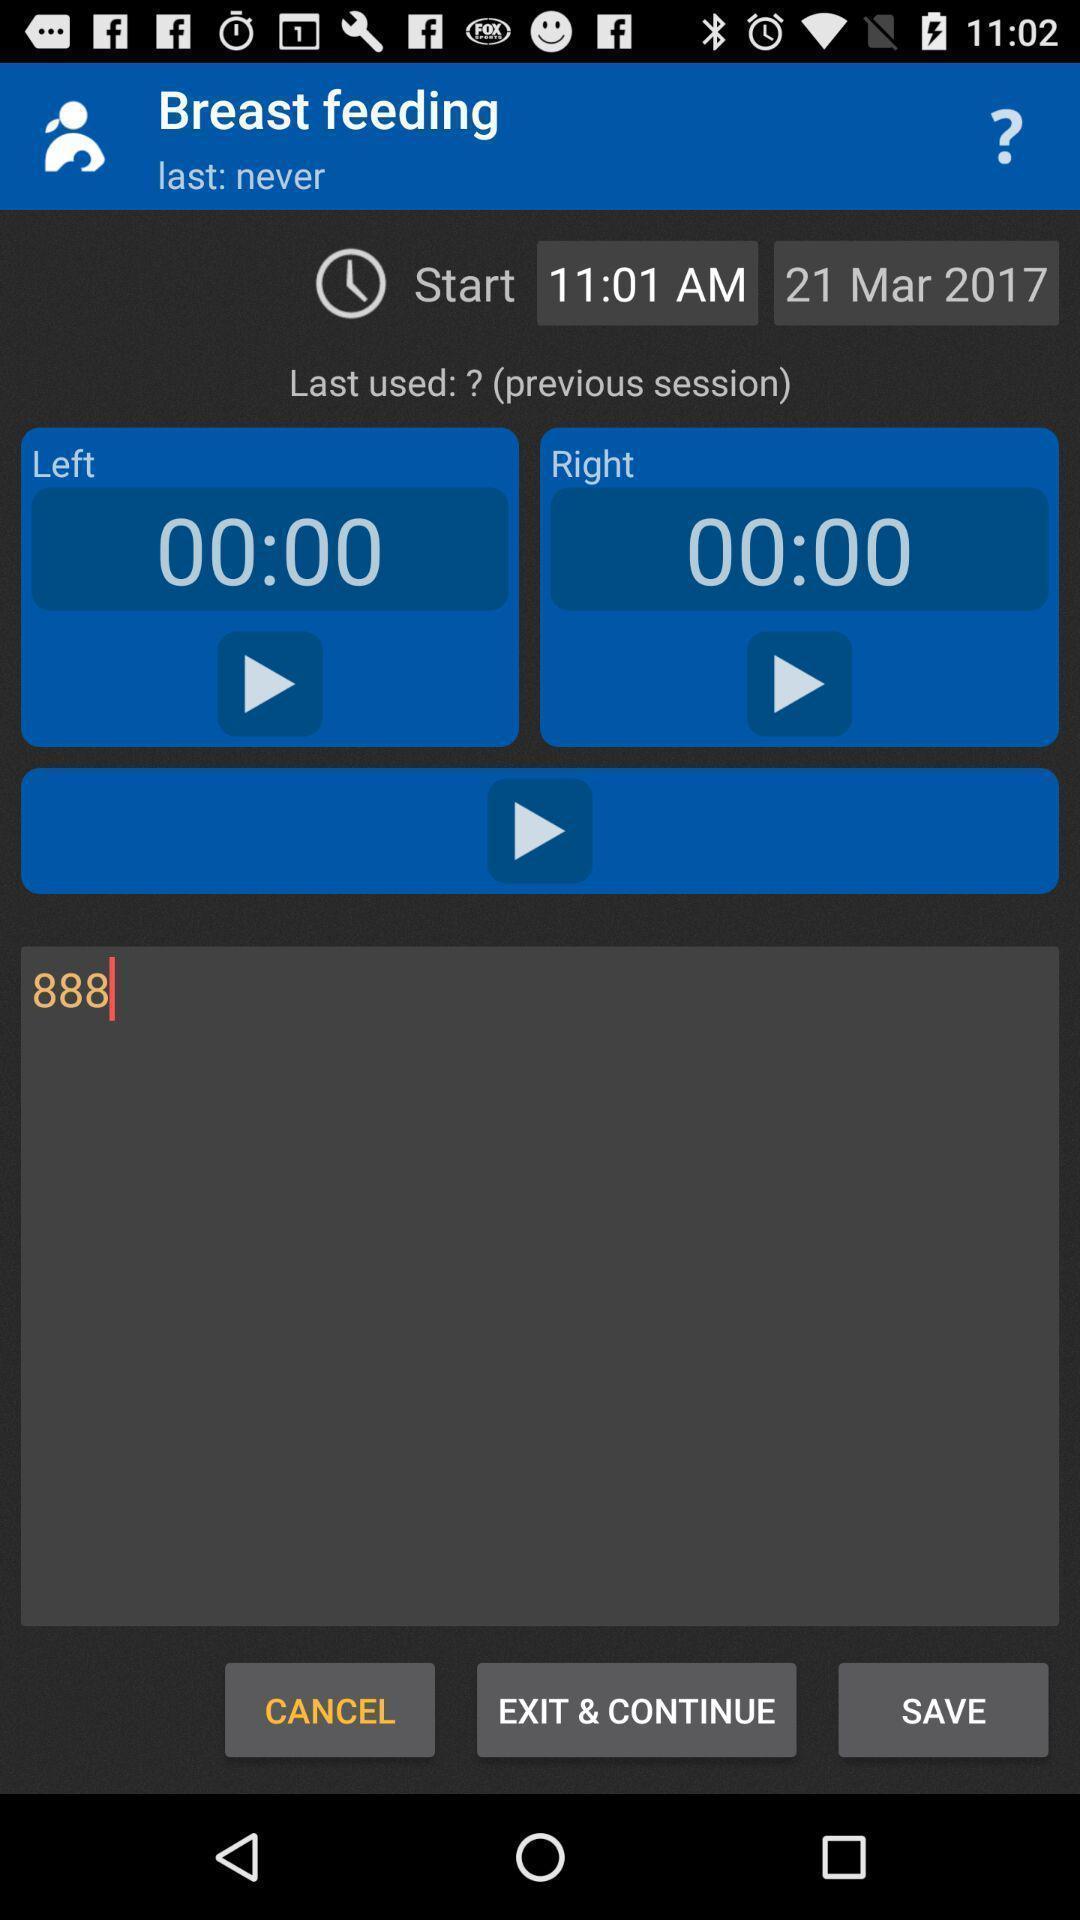What can you discern from this picture? Page displaying time and date reminding to feed a baby. 